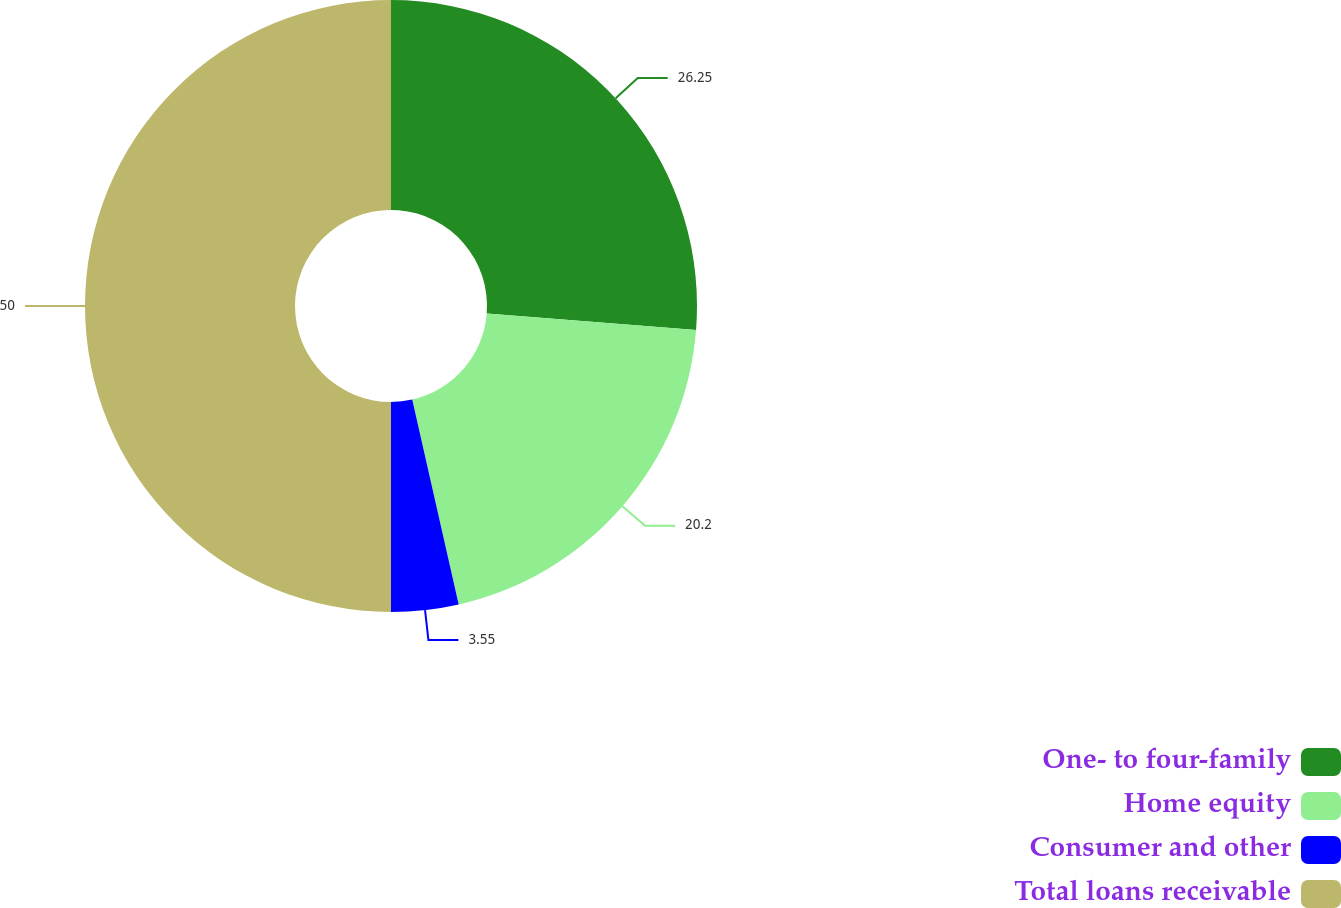Convert chart to OTSL. <chart><loc_0><loc_0><loc_500><loc_500><pie_chart><fcel>One- to four-family<fcel>Home equity<fcel>Consumer and other<fcel>Total loans receivable<nl><fcel>26.25%<fcel>20.2%<fcel>3.55%<fcel>50.0%<nl></chart> 